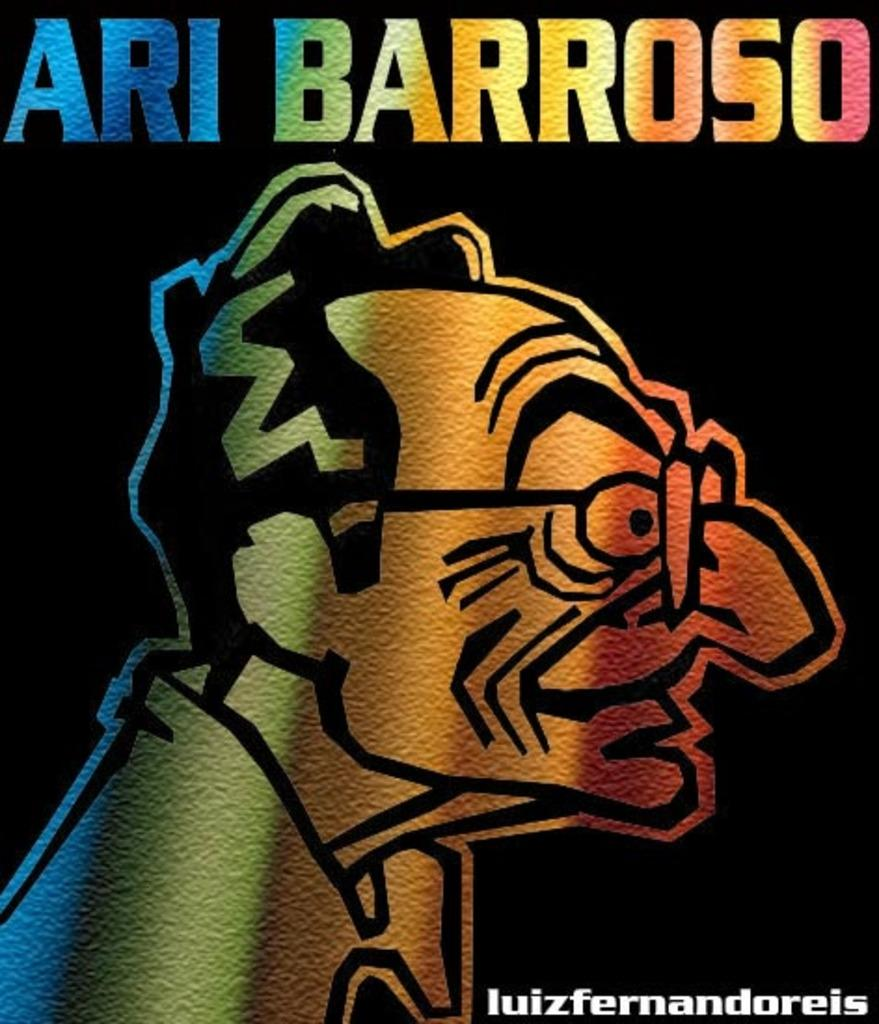<image>
Write a terse but informative summary of the picture. A very colorful and drawn cartoon picture of Ari Barroso. 